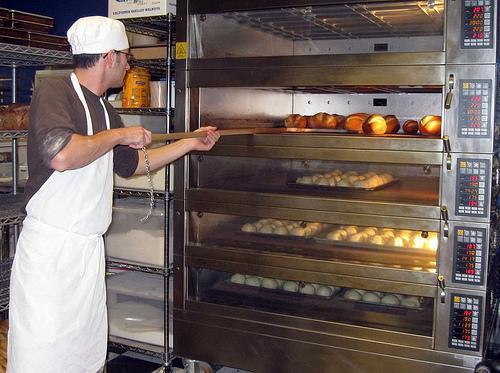How many people are baking?
Give a very brief answer. 1. How many bread ovens are visible?
Give a very brief answer. 5. How many trays of uncooked bread are present in the image?
Give a very brief answer. 5. 